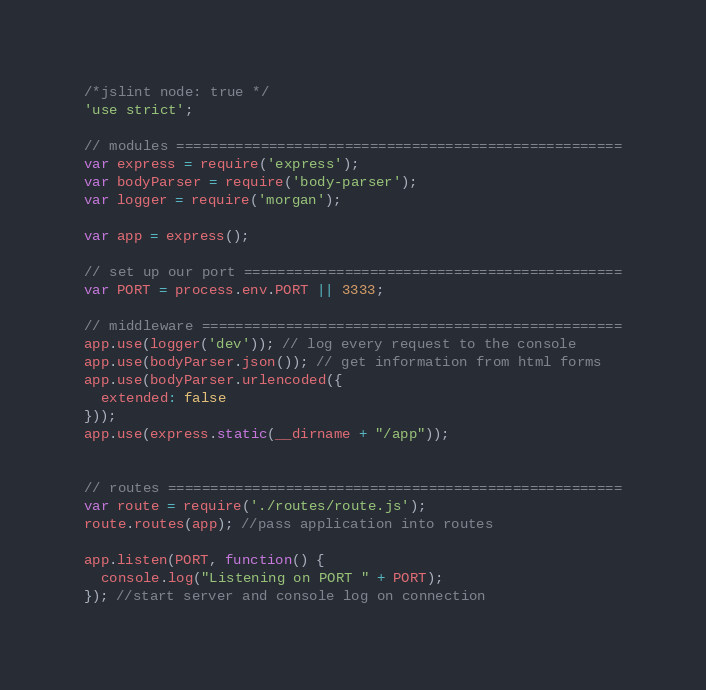<code> <loc_0><loc_0><loc_500><loc_500><_JavaScript_>/*jslint node: true */
'use strict';

// modules =====================================================
var express = require('express');
var bodyParser = require('body-parser');
var logger = require('morgan');

var app = express();

// set up our port =============================================
var PORT = process.env.PORT || 3333;

// middleware ==================================================
app.use(logger('dev')); // log every request to the console
app.use(bodyParser.json()); // get information from html forms
app.use(bodyParser.urlencoded({
  extended: false
}));
app.use(express.static(__dirname + "/app"));


// routes ======================================================
var route = require('./routes/route.js');
route.routes(app); //pass application into routes

app.listen(PORT, function() {
  console.log("Listening on PORT " + PORT);
}); //start server and console log on connection
</code> 